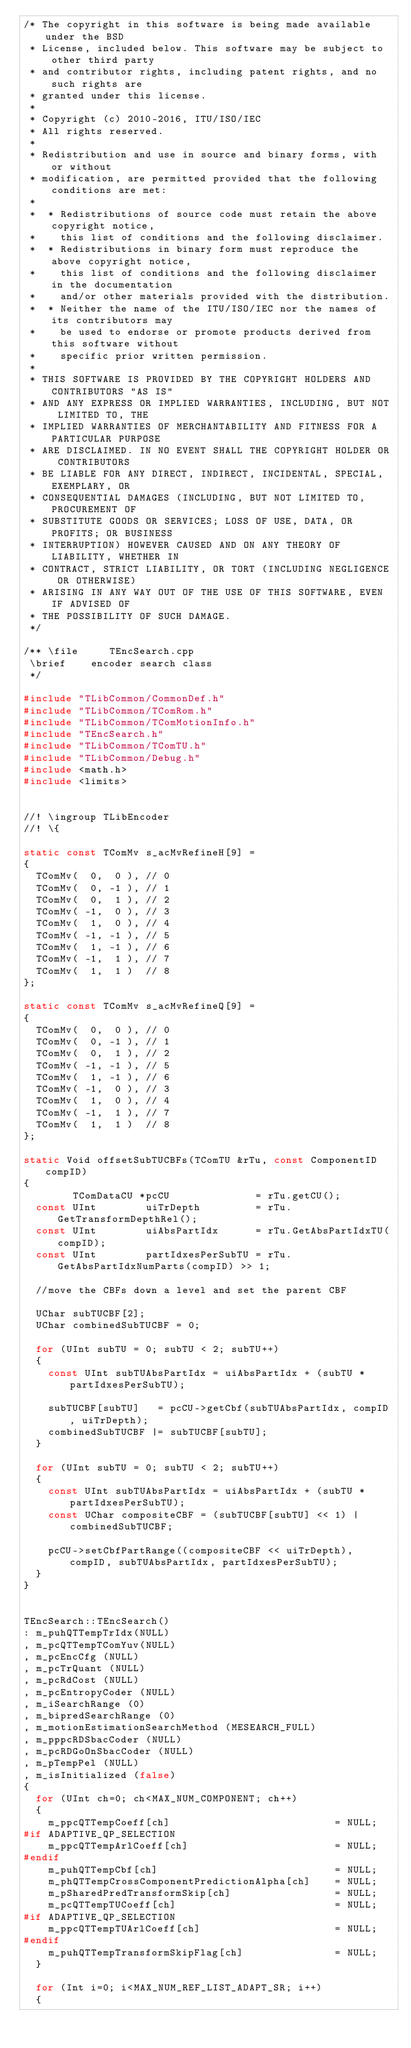<code> <loc_0><loc_0><loc_500><loc_500><_C++_>/* The copyright in this software is being made available under the BSD
 * License, included below. This software may be subject to other third party
 * and contributor rights, including patent rights, and no such rights are
 * granted under this license.
 *
 * Copyright (c) 2010-2016, ITU/ISO/IEC
 * All rights reserved.
 *
 * Redistribution and use in source and binary forms, with or without
 * modification, are permitted provided that the following conditions are met:
 *
 *  * Redistributions of source code must retain the above copyright notice,
 *    this list of conditions and the following disclaimer.
 *  * Redistributions in binary form must reproduce the above copyright notice,
 *    this list of conditions and the following disclaimer in the documentation
 *    and/or other materials provided with the distribution.
 *  * Neither the name of the ITU/ISO/IEC nor the names of its contributors may
 *    be used to endorse or promote products derived from this software without
 *    specific prior written permission.
 *
 * THIS SOFTWARE IS PROVIDED BY THE COPYRIGHT HOLDERS AND CONTRIBUTORS "AS IS"
 * AND ANY EXPRESS OR IMPLIED WARRANTIES, INCLUDING, BUT NOT LIMITED TO, THE
 * IMPLIED WARRANTIES OF MERCHANTABILITY AND FITNESS FOR A PARTICULAR PURPOSE
 * ARE DISCLAIMED. IN NO EVENT SHALL THE COPYRIGHT HOLDER OR CONTRIBUTORS
 * BE LIABLE FOR ANY DIRECT, INDIRECT, INCIDENTAL, SPECIAL, EXEMPLARY, OR
 * CONSEQUENTIAL DAMAGES (INCLUDING, BUT NOT LIMITED TO, PROCUREMENT OF
 * SUBSTITUTE GOODS OR SERVICES; LOSS OF USE, DATA, OR PROFITS; OR BUSINESS
 * INTERRUPTION) HOWEVER CAUSED AND ON ANY THEORY OF LIABILITY, WHETHER IN
 * CONTRACT, STRICT LIABILITY, OR TORT (INCLUDING NEGLIGENCE OR OTHERWISE)
 * ARISING IN ANY WAY OUT OF THE USE OF THIS SOFTWARE, EVEN IF ADVISED OF
 * THE POSSIBILITY OF SUCH DAMAGE.
 */

/** \file     TEncSearch.cpp
 \brief    encoder search class
 */

#include "TLibCommon/CommonDef.h"
#include "TLibCommon/TComRom.h"
#include "TLibCommon/TComMotionInfo.h"
#include "TEncSearch.h"
#include "TLibCommon/TComTU.h"
#include "TLibCommon/Debug.h"
#include <math.h>
#include <limits>


//! \ingroup TLibEncoder
//! \{

static const TComMv s_acMvRefineH[9] =
{
  TComMv(  0,  0 ), // 0
  TComMv(  0, -1 ), // 1
  TComMv(  0,  1 ), // 2
  TComMv( -1,  0 ), // 3
  TComMv(  1,  0 ), // 4
  TComMv( -1, -1 ), // 5
  TComMv(  1, -1 ), // 6
  TComMv( -1,  1 ), // 7
  TComMv(  1,  1 )  // 8
};

static const TComMv s_acMvRefineQ[9] =
{
  TComMv(  0,  0 ), // 0
  TComMv(  0, -1 ), // 1
  TComMv(  0,  1 ), // 2
  TComMv( -1, -1 ), // 5
  TComMv(  1, -1 ), // 6
  TComMv( -1,  0 ), // 3
  TComMv(  1,  0 ), // 4
  TComMv( -1,  1 ), // 7
  TComMv(  1,  1 )  // 8
};

static Void offsetSubTUCBFs(TComTU &rTu, const ComponentID compID)
{
        TComDataCU *pcCU              = rTu.getCU();
  const UInt        uiTrDepth         = rTu.GetTransformDepthRel();
  const UInt        uiAbsPartIdx      = rTu.GetAbsPartIdxTU(compID);
  const UInt        partIdxesPerSubTU = rTu.GetAbsPartIdxNumParts(compID) >> 1;

  //move the CBFs down a level and set the parent CBF

  UChar subTUCBF[2];
  UChar combinedSubTUCBF = 0;

  for (UInt subTU = 0; subTU < 2; subTU++)
  {
    const UInt subTUAbsPartIdx = uiAbsPartIdx + (subTU * partIdxesPerSubTU);

    subTUCBF[subTU]   = pcCU->getCbf(subTUAbsPartIdx, compID, uiTrDepth);
    combinedSubTUCBF |= subTUCBF[subTU];
  }

  for (UInt subTU = 0; subTU < 2; subTU++)
  {
    const UInt subTUAbsPartIdx = uiAbsPartIdx + (subTU * partIdxesPerSubTU);
    const UChar compositeCBF = (subTUCBF[subTU] << 1) | combinedSubTUCBF;

    pcCU->setCbfPartRange((compositeCBF << uiTrDepth), compID, subTUAbsPartIdx, partIdxesPerSubTU);
  }
}


TEncSearch::TEncSearch()
: m_puhQTTempTrIdx(NULL)
, m_pcQTTempTComYuv(NULL)
, m_pcEncCfg (NULL)
, m_pcTrQuant (NULL)
, m_pcRdCost (NULL)
, m_pcEntropyCoder (NULL)
, m_iSearchRange (0)
, m_bipredSearchRange (0)
, m_motionEstimationSearchMethod (MESEARCH_FULL)
, m_pppcRDSbacCoder (NULL)
, m_pcRDGoOnSbacCoder (NULL)
, m_pTempPel (NULL)
, m_isInitialized (false)
{
  for (UInt ch=0; ch<MAX_NUM_COMPONENT; ch++)
  {
    m_ppcQTTempCoeff[ch]                           = NULL;
#if ADAPTIVE_QP_SELECTION
    m_ppcQTTempArlCoeff[ch]                        = NULL;
#endif
    m_puhQTTempCbf[ch]                             = NULL;
    m_phQTTempCrossComponentPredictionAlpha[ch]    = NULL;
    m_pSharedPredTransformSkip[ch]                 = NULL;
    m_pcQTTempTUCoeff[ch]                          = NULL;
#if ADAPTIVE_QP_SELECTION
    m_ppcQTTempTUArlCoeff[ch]                      = NULL;
#endif
    m_puhQTTempTransformSkipFlag[ch]               = NULL;
  }

  for (Int i=0; i<MAX_NUM_REF_LIST_ADAPT_SR; i++)
  {</code> 